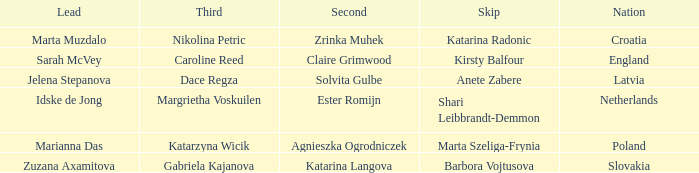Which Lead has Katarina Radonic as Skip? Marta Muzdalo. 